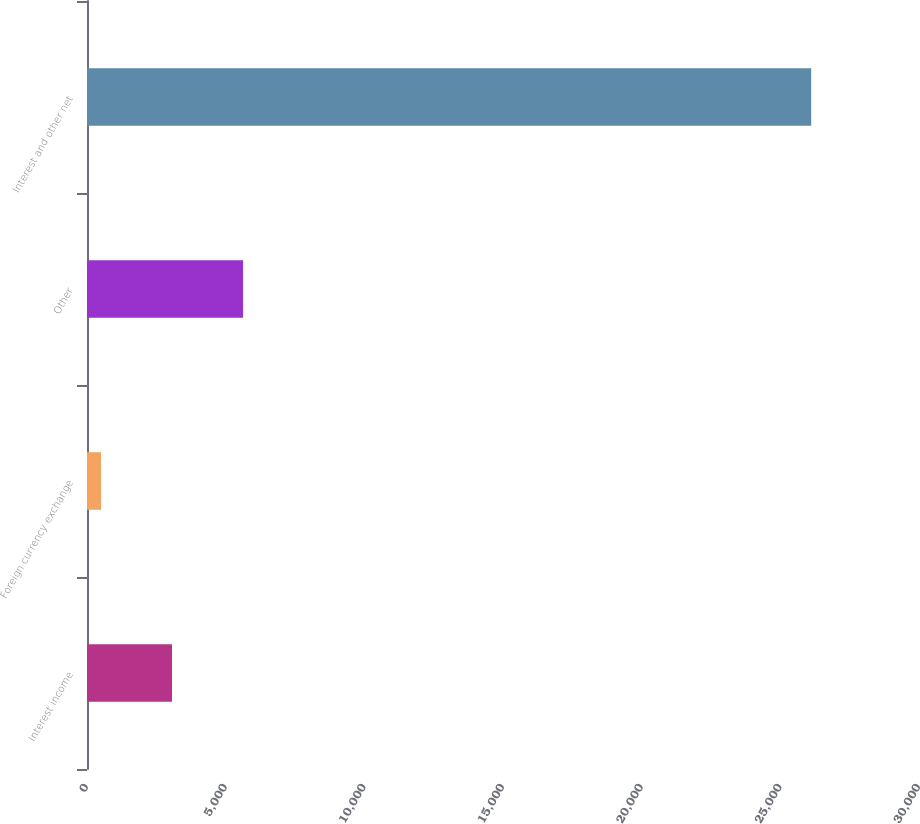<chart> <loc_0><loc_0><loc_500><loc_500><bar_chart><fcel>Interest income<fcel>Foreign currency exchange<fcel>Other<fcel>Interest and other net<nl><fcel>3065.8<fcel>505<fcel>5626.6<fcel>26113<nl></chart> 